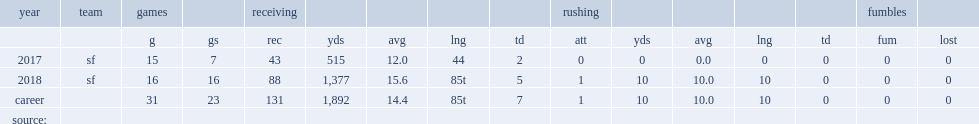How many receptions did kittle get in 2017? 43.0. 